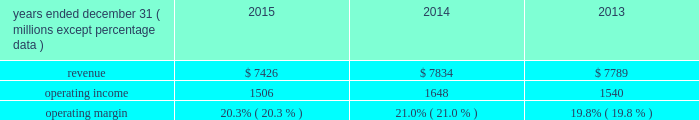( 2 ) in 2013 , our principal u.k subsidiary agreed with the trustees of one of the u.k .
Plans to contribute an average of $ 11 million per year to that pension plan for the next three years .
The trustees of the plan have certain rights to request that our u.k .
Subsidiary advance an amount equal to an actuarially determined winding-up deficit .
As of december 31 , 2015 , the estimated winding-up deficit was a3240 million ( $ 360 million at december 31 , 2015 exchange rates ) .
The trustees of the plan have accepted in practice the agreed-upon schedule of contributions detailed above and have not requested the winding-up deficit be paid .
( 3 ) purchase obligations are defined as agreements to purchase goods and services that are enforceable and legally binding on us , and that specifies all significant terms , including what is to be purchased , at what price and the approximate timing of the transaction .
Most of our purchase obligations are related to purchases of information technology services or other service contracts .
( 4 ) excludes $ 12 million of unfunded commitments related to an investment in a limited partnership due to our inability to reasonably estimate the period ( s ) when the limited partnership will request funding .
( 5 ) excludes $ 218 million of liabilities for uncertain tax positions due to our inability to reasonably estimate the period ( s ) when potential cash settlements will be made .
Financial condition at december 31 , 2015 , our net assets were $ 6.2 billion , representing total assets minus total liabilities , a decrease from $ 6.6 billion at december 31 , 2014 .
The decrease was due primarily to share repurchases of $ 1.6 billion , dividends of $ 323 million , and an increase in accumulated other comprehensive loss of $ 289 million related primarily to an increase in the post- retirement benefit obligation , partially offset by net income of $ 1.4 billion for the year ended december 31 , 2015 .
Working capital increased by $ 77 million from $ 809 million at december 31 , 2014 to $ 886 million at december 31 , 2015 .
Accumulated other comprehensive loss increased $ 289 million at december 31 , 2015 as compared to december 31 , 2014 , which was primarily driven by the following : 2022 negative net foreign currency translation adjustments of $ 436 million , which are attributable to the strengthening of the u.s .
Dollar against certain foreign currencies , 2022 a decrease of $ 155 million in net post-retirement benefit obligations , and 2022 net financial instrument losses of $ 8 million .
Review by segment general we serve clients through the following segments : 2022 risk solutions acts as an advisor and insurance and reinsurance broker , helping clients manage their risks , via consultation , as well as negotiation and placement of insurance risk with insurance carriers through our global distribution network .
2022 hr solutions partners with organizations to solve their most complex benefits , talent and related financial challenges , and improve business performance by designing , implementing , communicating and administering a wide range of human capital , retirement , investment management , health care , compensation and talent management strategies .
Risk solutions .
The demand for property and casualty insurance generally rises as the overall level of economic activity increases and generally falls as such activity decreases , affecting both the commissions and fees generated by our brokerage business .
The economic activity that impacts property and casualty insurance is described as exposure units , and is most closely correlated .
What was the average revenue from 2013 to 2015? 
Computations: (((7789 + (7426 + 7834)) + 3) / 2)
Answer: 11526.0. 